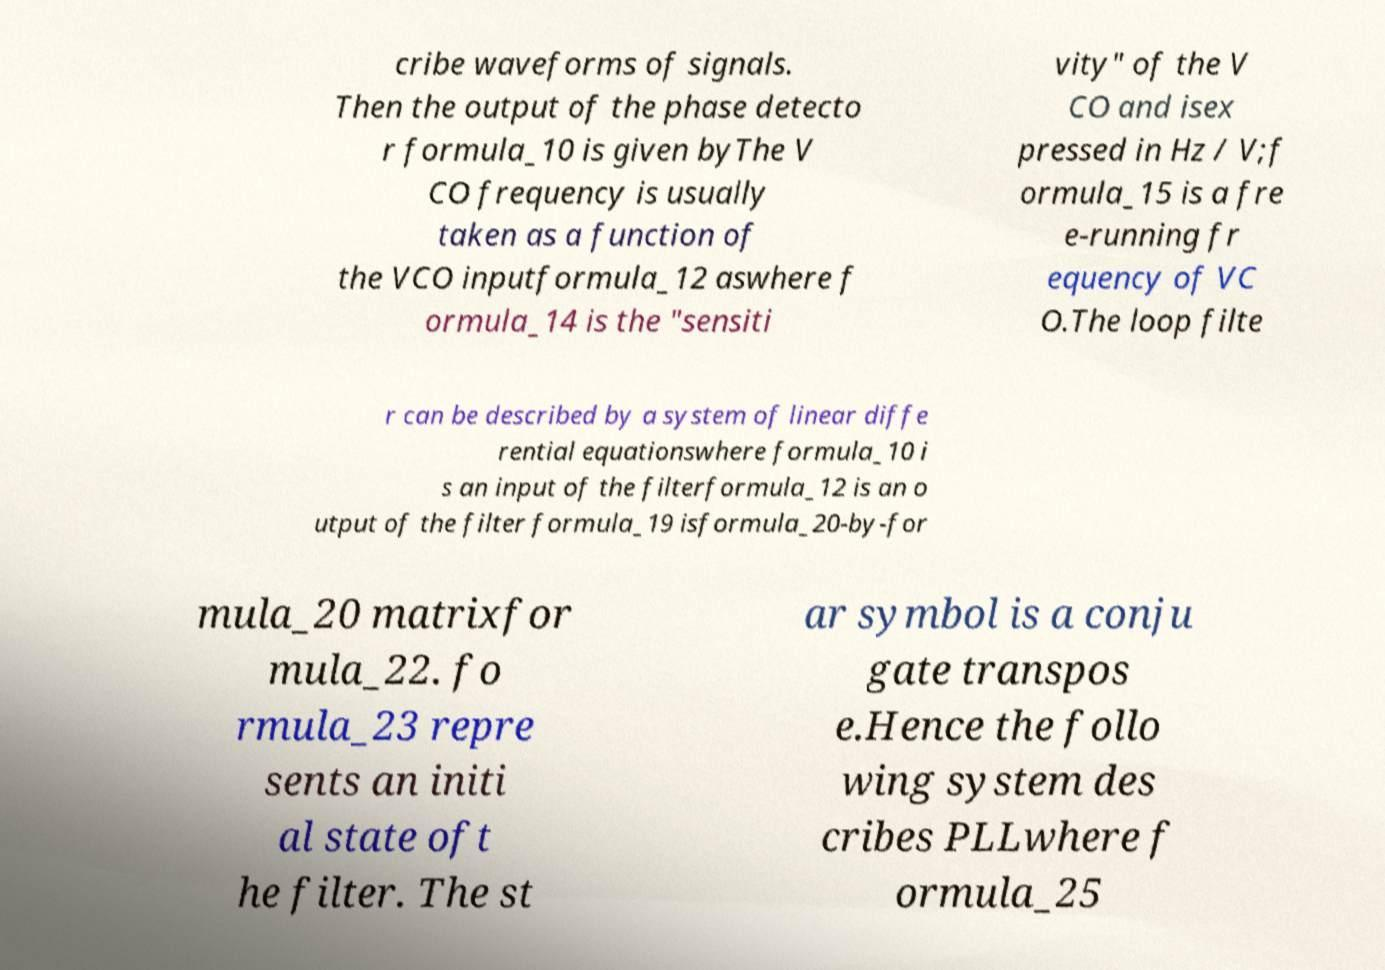Could you assist in decoding the text presented in this image and type it out clearly? cribe waveforms of signals. Then the output of the phase detecto r formula_10 is given byThe V CO frequency is usually taken as a function of the VCO inputformula_12 aswhere f ormula_14 is the "sensiti vity" of the V CO and isex pressed in Hz / V;f ormula_15 is a fre e-running fr equency of VC O.The loop filte r can be described by a system of linear diffe rential equationswhere formula_10 i s an input of the filterformula_12 is an o utput of the filter formula_19 isformula_20-by-for mula_20 matrixfor mula_22. fo rmula_23 repre sents an initi al state oft he filter. The st ar symbol is a conju gate transpos e.Hence the follo wing system des cribes PLLwhere f ormula_25 